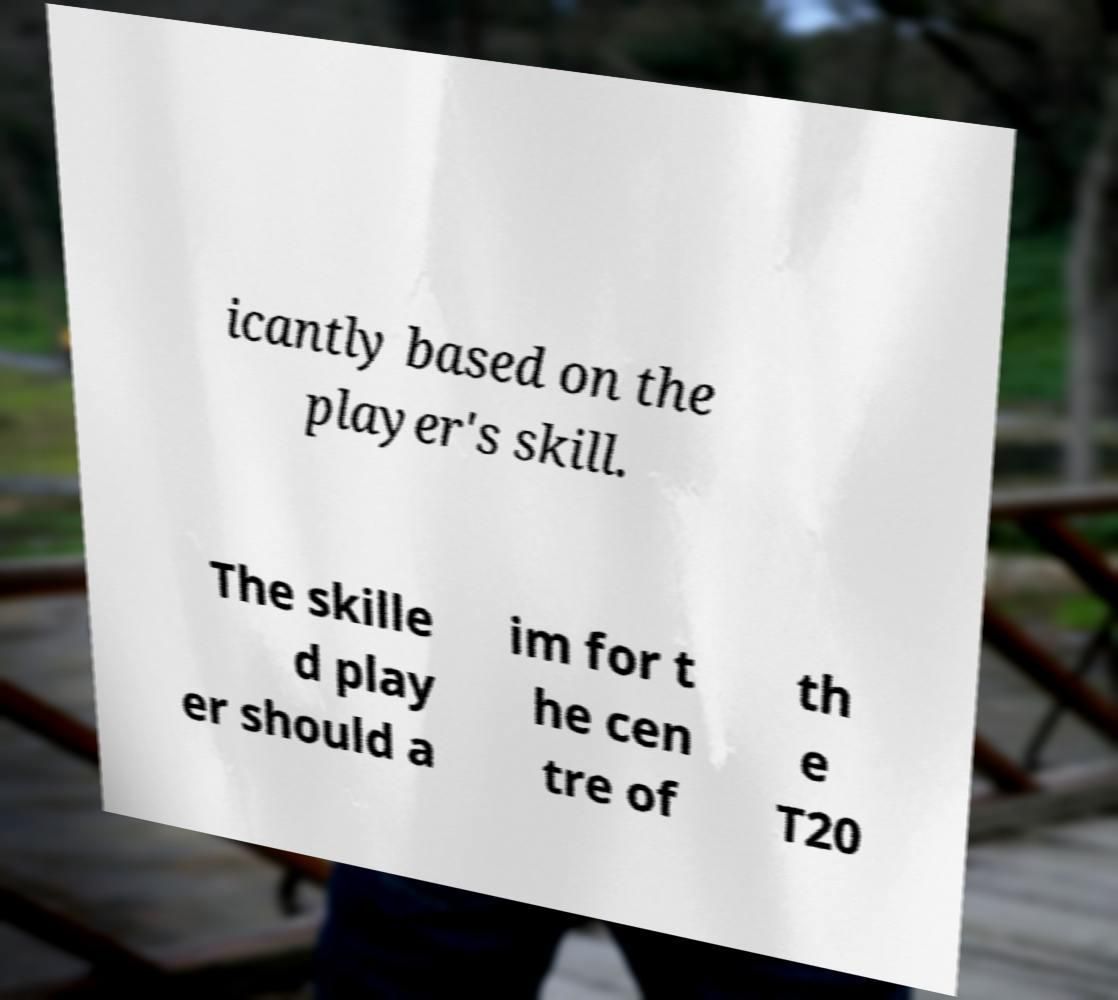Please read and relay the text visible in this image. What does it say? icantly based on the player's skill. The skille d play er should a im for t he cen tre of th e T20 